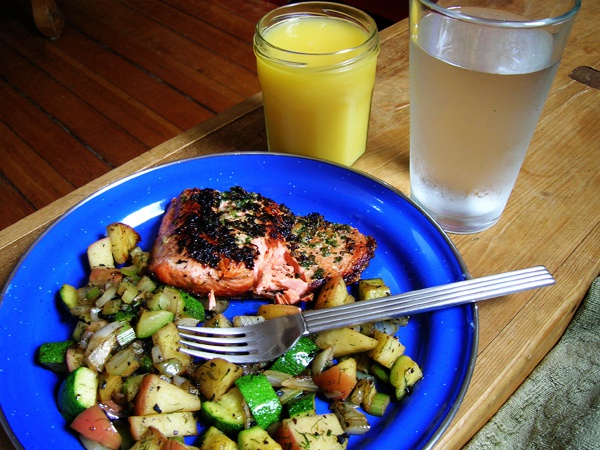Describe the objects in this image and their specific colors. I can see dining table in black, tan, and olive tones, cup in black, tan, darkgray, and gray tones, cup in black, khaki, and olive tones, fork in black, white, gray, and darkgray tones, and apple in black, khaki, tan, and maroon tones in this image. 